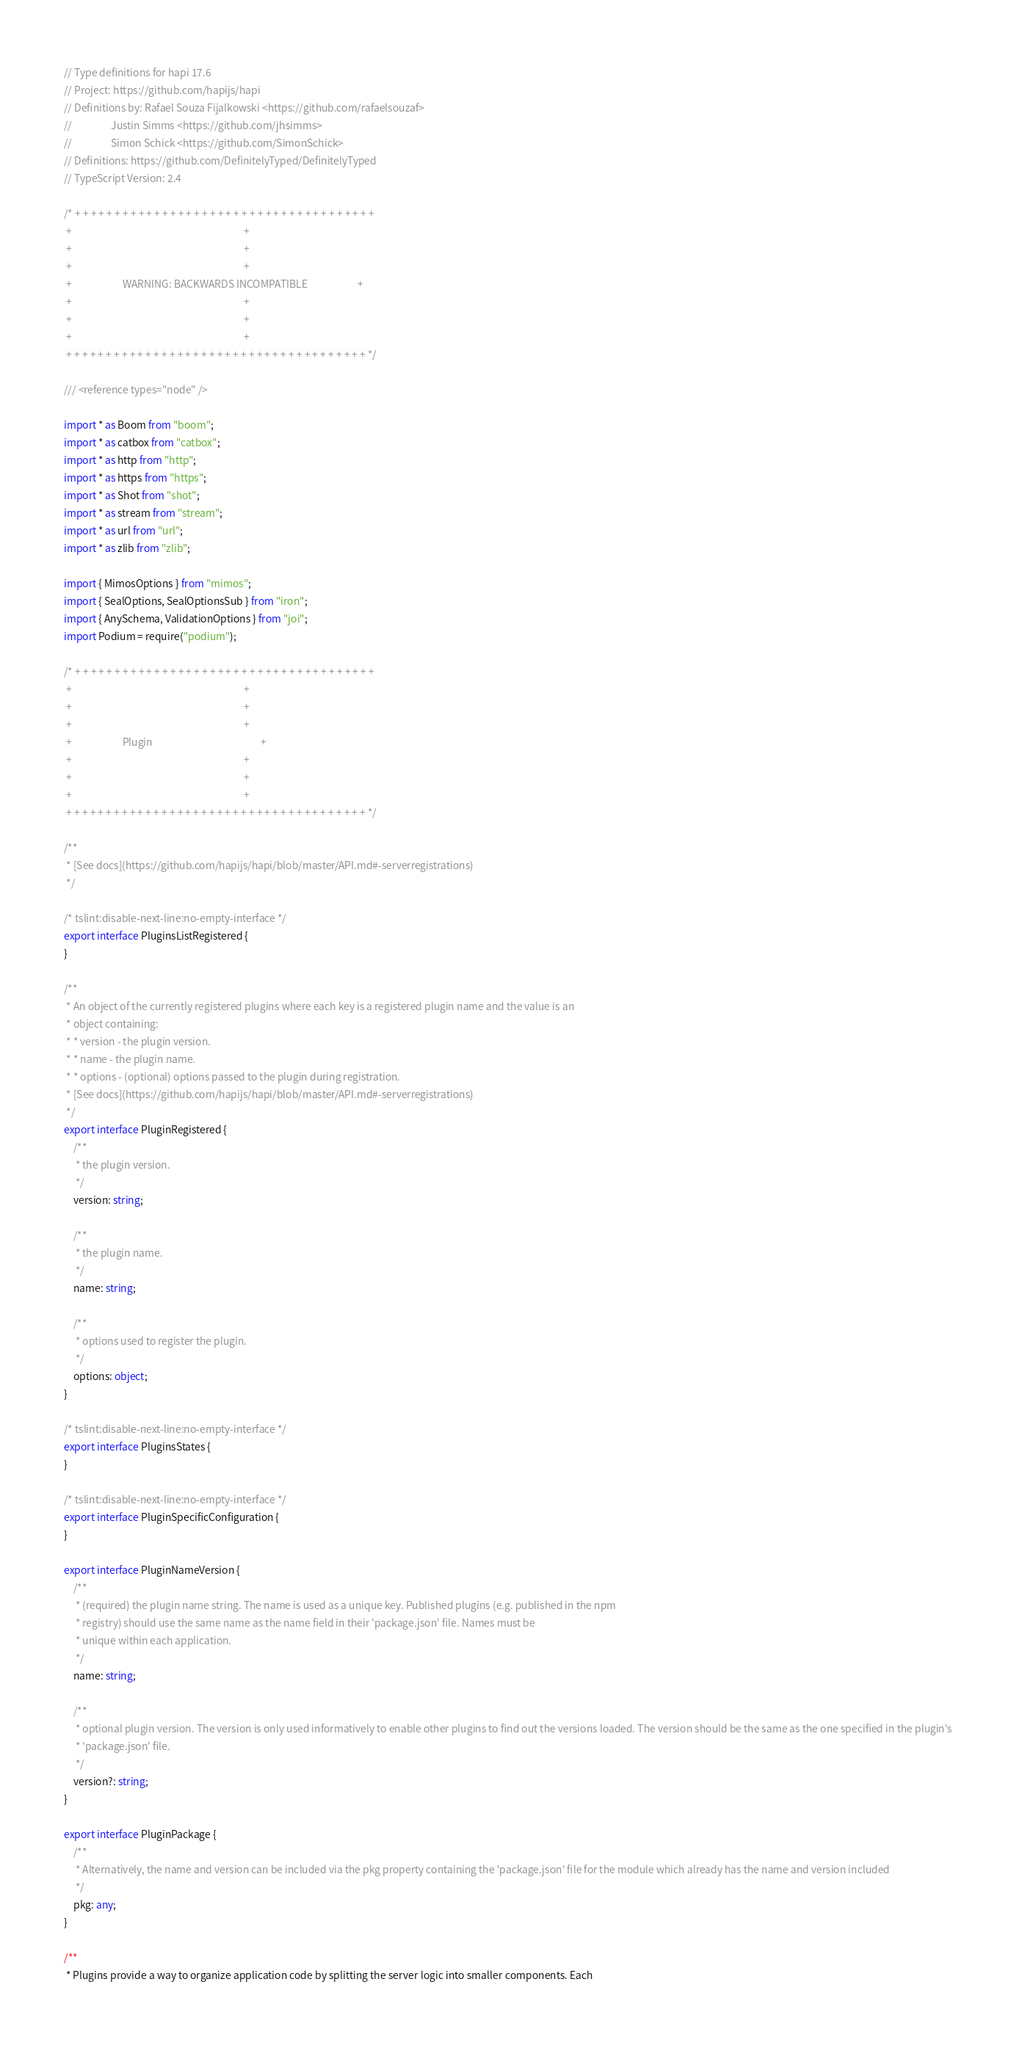<code> <loc_0><loc_0><loc_500><loc_500><_TypeScript_>// Type definitions for hapi 17.6
// Project: https://github.com/hapijs/hapi
// Definitions by: Rafael Souza Fijalkowski <https://github.com/rafaelsouzaf>
//                 Justin Simms <https://github.com/jhsimms>
//                 Simon Schick <https://github.com/SimonSchick>
// Definitions: https://github.com/DefinitelyTyped/DefinitelyTyped
// TypeScript Version: 2.4

/* + + + + + + + + + + + + + + + + + + + + + + + + + + + + + + + + + + + + + +
 +                                                                           +
 +                                                                           +
 +                                                                           +
 +                      WARNING: BACKWARDS INCOMPATIBLE                      +
 +                                                                           +
 +                                                                           +
 +                                                                           +
 + + + + + + + + + + + + + + + + + + + + + + + + + + + + + + + + + + + + + + */

/// <reference types="node" />

import * as Boom from "boom";
import * as catbox from "catbox";
import * as http from "http";
import * as https from "https";
import * as Shot from "shot";
import * as stream from "stream";
import * as url from "url";
import * as zlib from "zlib";

import { MimosOptions } from "mimos";
import { SealOptions, SealOptionsSub } from "iron";
import { AnySchema, ValidationOptions } from "joi";
import Podium = require("podium");

/* + + + + + + + + + + + + + + + + + + + + + + + + + + + + + + + + + + + + + +
 +                                                                           +
 +                                                                           +
 +                                                                           +
 +                      Plugin                                               +
 +                                                                           +
 +                                                                           +
 +                                                                           +
 + + + + + + + + + + + + + + + + + + + + + + + + + + + + + + + + + + + + + + */

/**
 * [See docs](https://github.com/hapijs/hapi/blob/master/API.md#-serverregistrations)
 */

/* tslint:disable-next-line:no-empty-interface */
export interface PluginsListRegistered {
}

/**
 * An object of the currently registered plugins where each key is a registered plugin name and the value is an
 * object containing:
 * * version - the plugin version.
 * * name - the plugin name.
 * * options - (optional) options passed to the plugin during registration.
 * [See docs](https://github.com/hapijs/hapi/blob/master/API.md#-serverregistrations)
 */
export interface PluginRegistered {
    /**
     * the plugin version.
     */
    version: string;

    /**
     * the plugin name.
     */
    name: string;

    /**
     * options used to register the plugin.
     */
    options: object;
}

/* tslint:disable-next-line:no-empty-interface */
export interface PluginsStates {
}

/* tslint:disable-next-line:no-empty-interface */
export interface PluginSpecificConfiguration {
}

export interface PluginNameVersion {
    /**
     * (required) the plugin name string. The name is used as a unique key. Published plugins (e.g. published in the npm
     * registry) should use the same name as the name field in their 'package.json' file. Names must be
     * unique within each application.
     */
    name: string;

    /**
     * optional plugin version. The version is only used informatively to enable other plugins to find out the versions loaded. The version should be the same as the one specified in the plugin's
     * 'package.json' file.
     */
    version?: string;
}

export interface PluginPackage {
    /**
     * Alternatively, the name and version can be included via the pkg property containing the 'package.json' file for the module which already has the name and version included
     */
    pkg: any;
}

/**
 * Plugins provide a way to organize application code by splitting the server logic into smaller components. Each</code> 